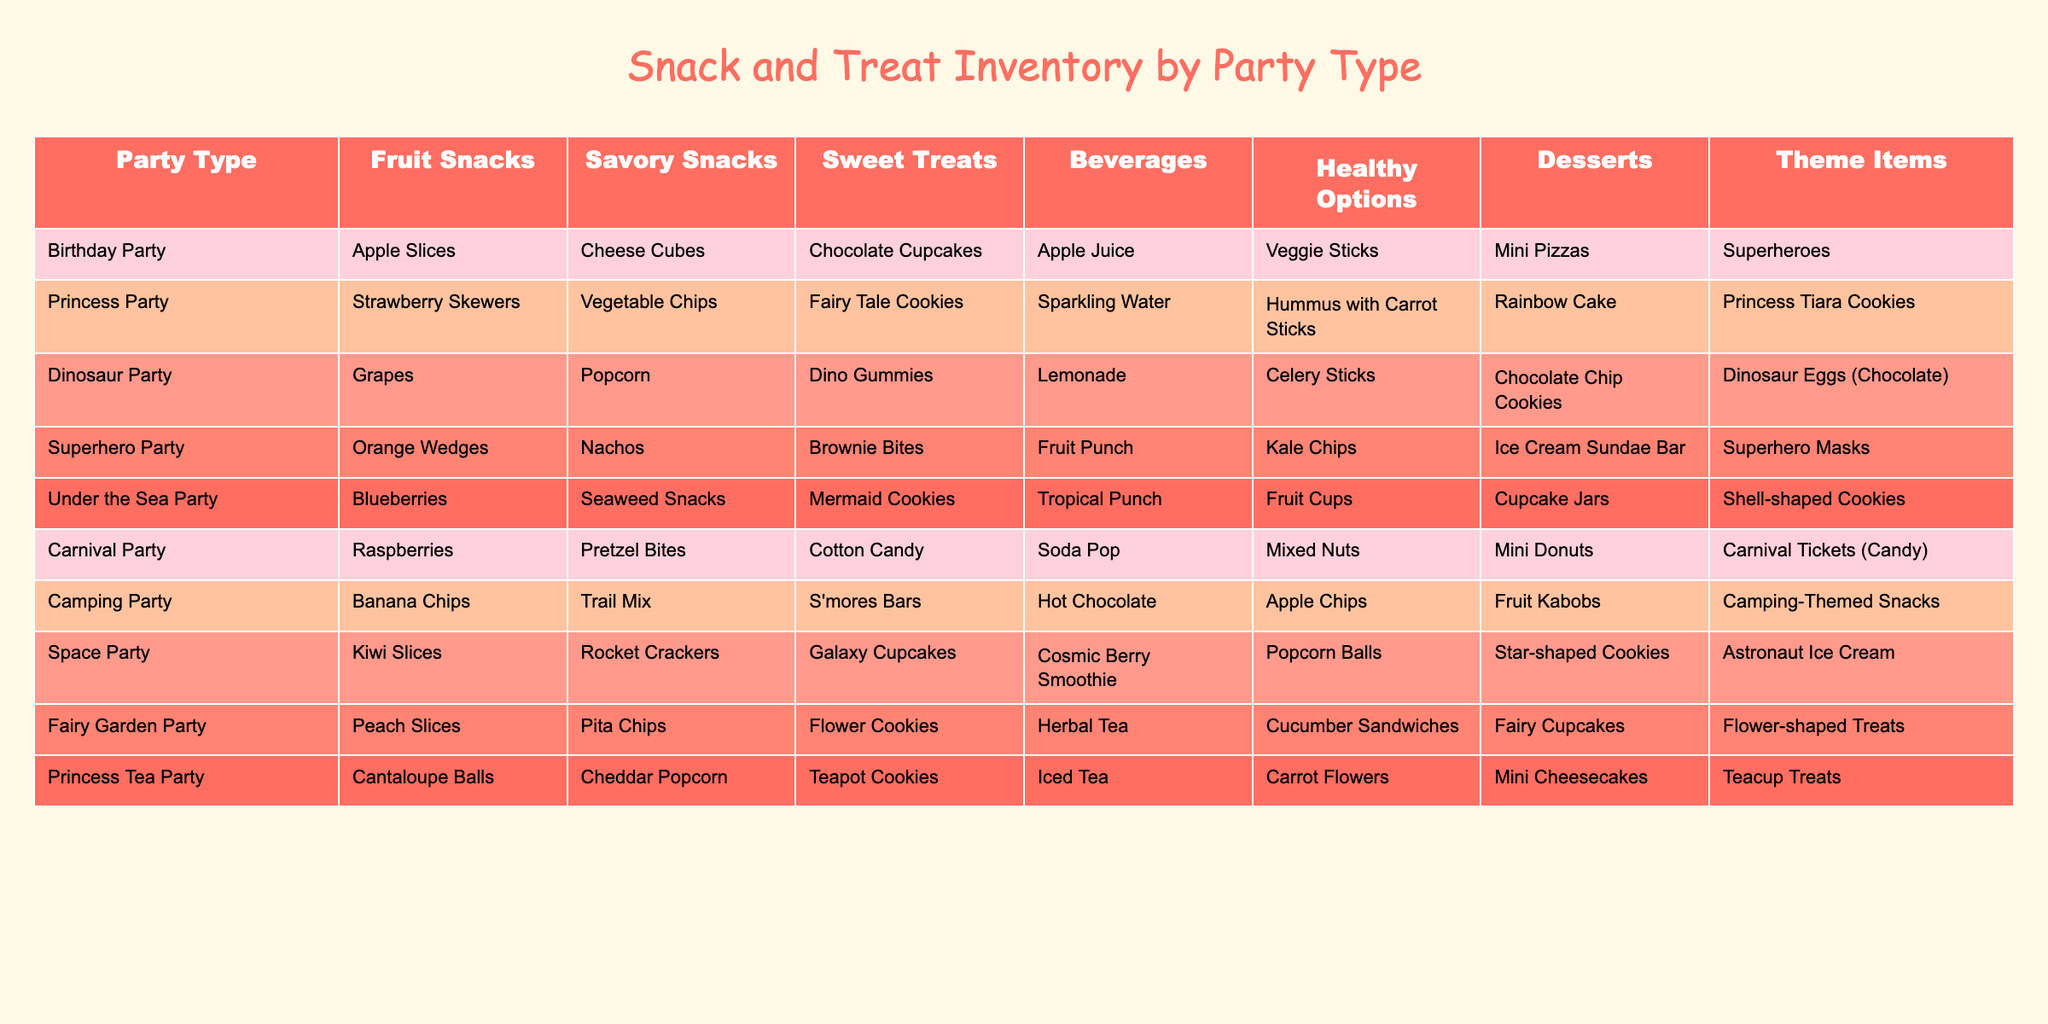What snacks are offered at the Dinosaur Party? The table lists "Grapes" as the fruit snack, "Popcorn" as the savory snack, "Dino Gummies" as the sweet treat, and "Lemonade" as the beverage for the Dinosaur Party.
Answer: Grapes, Popcorn, Dino Gummies, Lemonade Which party has the most variety in snack options? To determine the party with the most variety, we count the number of different categories listed for each party: Birthday Party (7), Princess Party (7), Dinosaur Party (7), Superhero Party (7), Under the Sea Party (7), Carnival Party (7), Camping Party (7), Space Party (7), Fairy Garden Party (7), and Princess Tea Party (7). All parties have the same variety.
Answer: All parties have the same variety Is there a party that does not include desserts? By examining the table, each party type is listed with a dessert option, meaning every party has desserts included.
Answer: No What is the total number of snack categories offered at a Princess Party? The Princess Party includes the following: "Fruit Snacks," "Savory Snacks," "Sweet Treats," "Beverages," "Healthy Options," and "Desserts." That makes a total of 6 snack categories.
Answer: 6 For a Birthday Party, how many healthy options and desserts are served? Looking at the Birthday Party row, the healthy option is "Veggie Sticks," and the dessert is "Mini Pizzas." Thus, there is one healthy option and one dessert.
Answer: 1 healthy option, 1 dessert What is the average number of snack categories per party type? There are 10 party types listed, and each one has 7 snack categories. The total number of categories is 10 x 7 = 70, therefore the average per party type is 70 / 10 = 7.
Answer: 7 Does the Carnival Party have more sweet treats than the Space Party? The Carnival Party has "Cotton Candy" as the sweet treat, while the Space Party has "Galaxy Cupcakes." Thus, the number of sweet treats is the same for both parties.
Answer: No, they have the same number Which theme has unique snacks not found in other parties? Upon reviewing the table, the "Dinosaur Party" offers "Dino Gummies" and "Dinosaur Eggs (Chocolate)," which are unique compared to snacks in other themes.
Answer: Dinosaur Party 